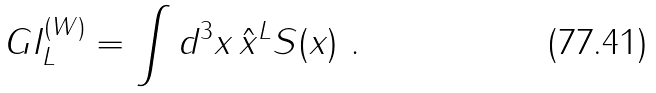Convert formula to latex. <formula><loc_0><loc_0><loc_500><loc_500>G I ^ { ( W ) } _ { L } = \int d ^ { 3 } { x } \, \hat { x } ^ { L } S ( { x } ) \ .</formula> 